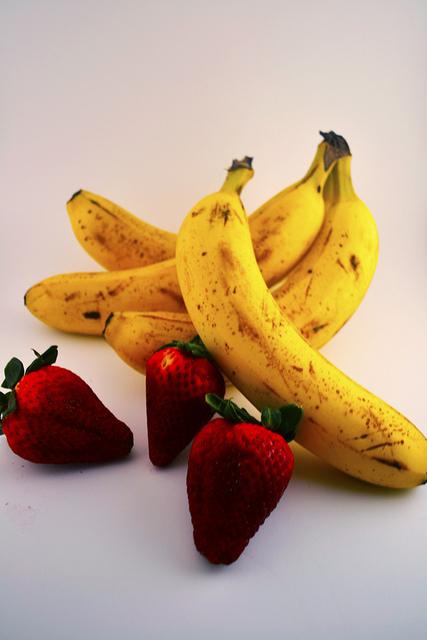How many pieces of fruit are there?
Write a very short answer. 7. What two fruits are present?
Be succinct. Banana and strawberries. Are these bananas ripe enough to eat?
Answer briefly. Yes. What are the bananas lying on?
Concise answer only. Table. 